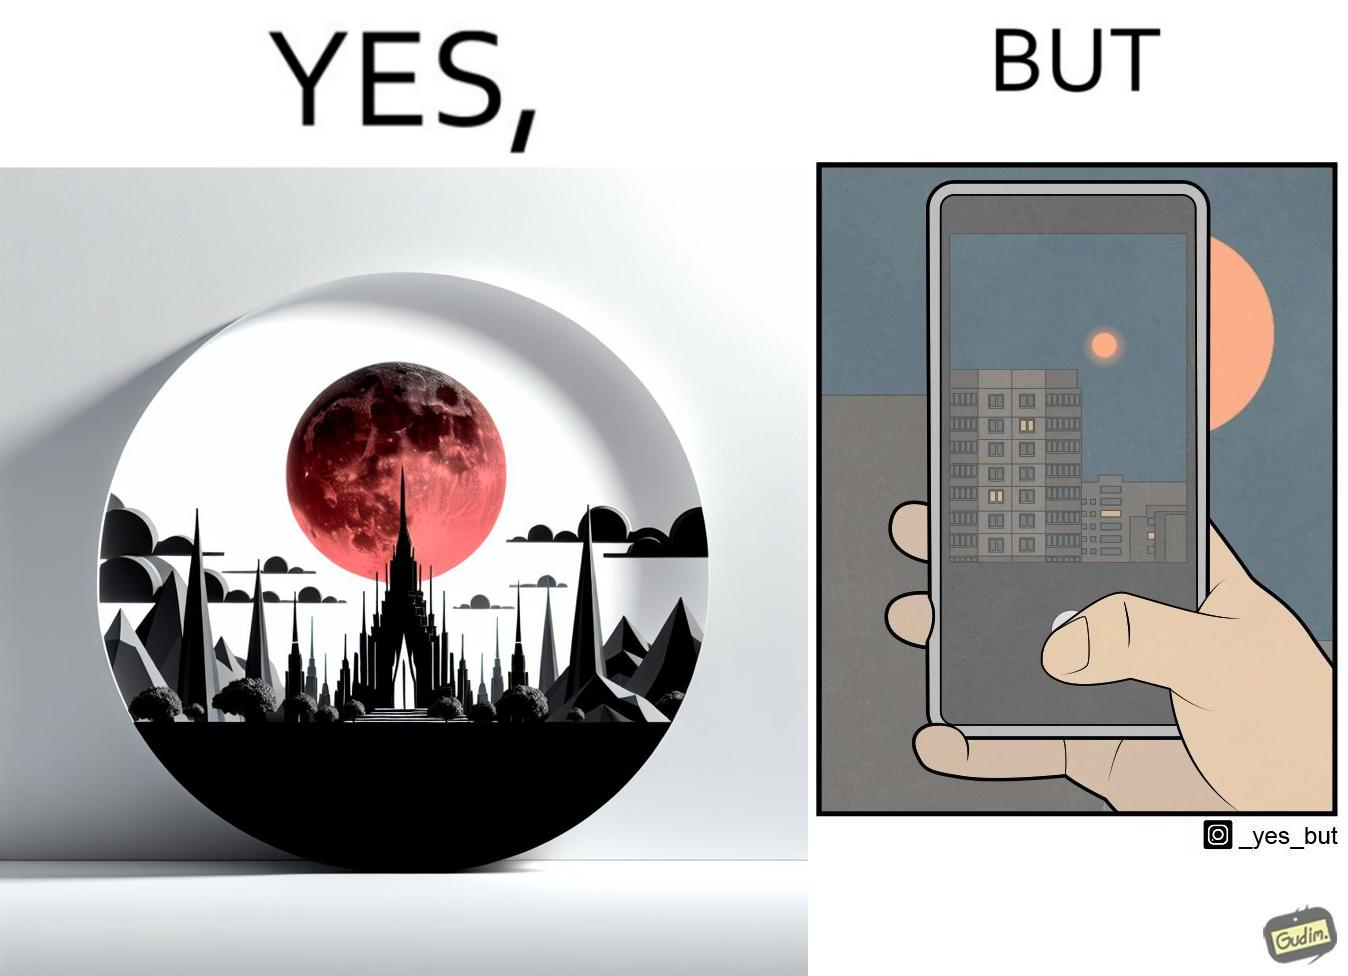What makes this image funny or satirical? The image is ironic, because the phone is not able to capture the real beauty of the view which the viewer can see by their naked eyes 